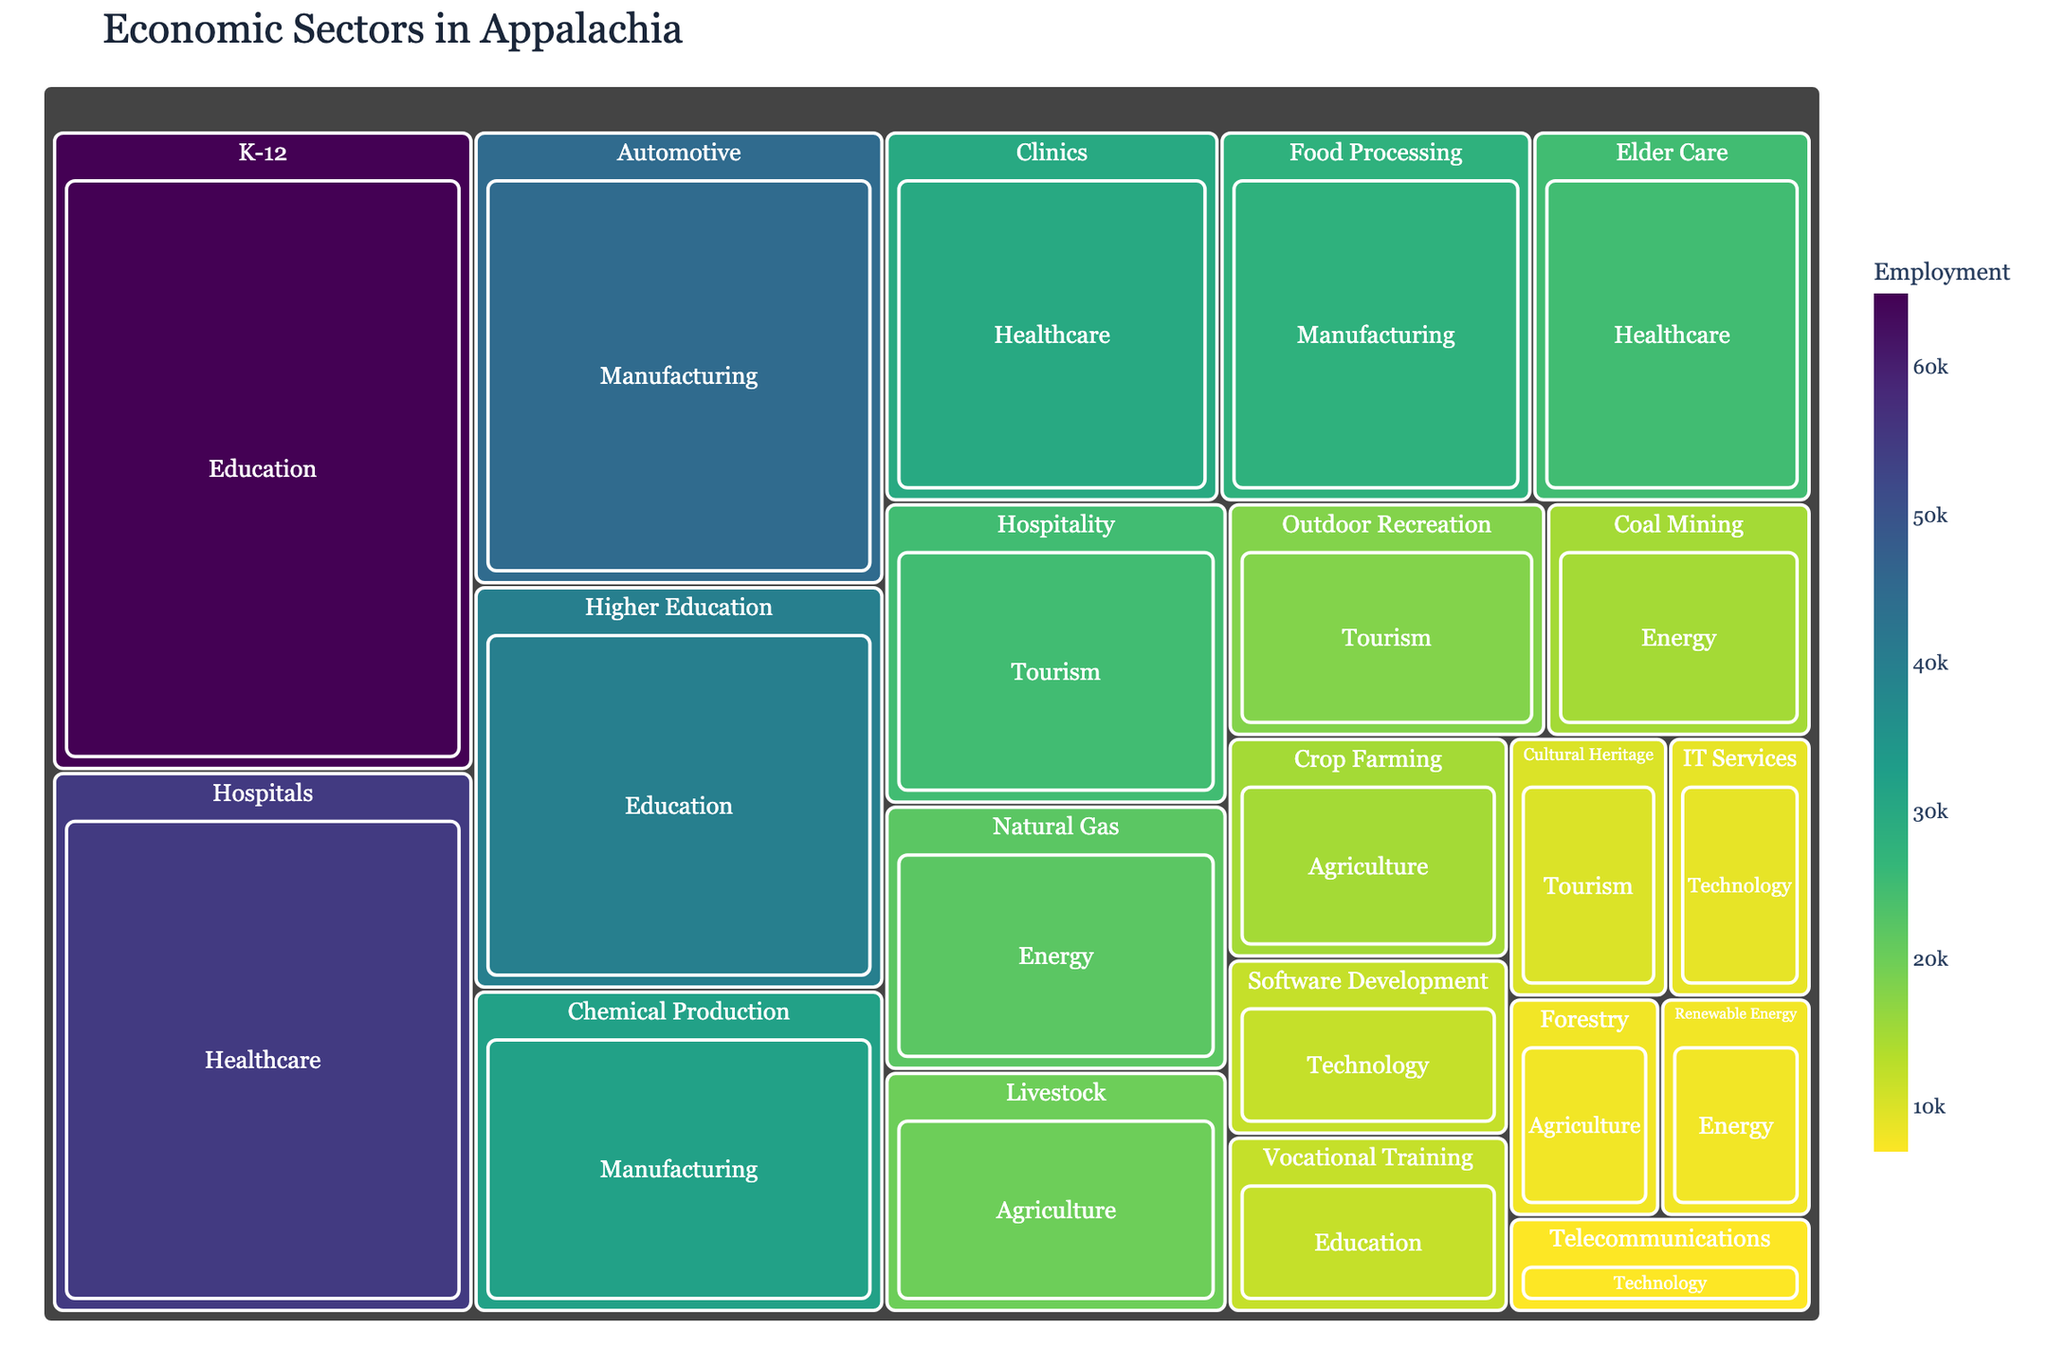Which industry has the highest employment in the Healthcare sector? Look at the sections within the Healthcare sector and find the industry with the largest area. The 'Hospitals' industry has the largest area, representing the highest employment.
Answer: Hospitals Which sector employs more people: Manufacturing or Education? Compare the total employment values from the Manufacturing and Education sectors shown in the treemap. Add the employment figures for each industry under both sectors and compare them.
Answer: Education What is the total employment in the Agriculture sector? Sum the employment values for all industries within the Agriculture sector: Livestock, Crop Farming, and Forestry. The total is 20,000 + 15,000 + 8,000 = 43,000.
Answer: 43,000 Which sector has the least employment? Identify the sector with the smallest area in the treemap. The Technology sector has the smallest overall area, indicating the least employment.
Answer: Technology How many more people are employed in K-12 education compared to Higher Education? Subtract the employment in Higher Education from that in K-12: 65,000 - 40,000. The result is 25,000 more people employed in K-12 education.
Answer: 25,000 In the Energy sector, which industry employs more people, Natural Gas or Coal Mining? Compare the employment values of the Natural Gas and Coal Mining industries within the Energy sector. Natural Gas employs 22,000, while Coal Mining employs 15,000. Hence, Natural Gas employs more people.
Answer: Natural Gas What percentage of the total employment in the Healthcare sector does Elder Care represent? Calculate the percentage of Elder Care employment out of the total Healthcare sector employment: (25,000 / (55,000 + 30,000 + 25,000)) * 100. The result is approximately 20.83%.
Answer: 20.83% Which industry in the Tourism sector has the second-highest employment? Identify the industries under the Tourism sector and find the one with the second-largest area after Hospitality. Outdoor Recreation has the second-highest employment with 18,000.
Answer: Outdoor Recreation What is the combined employment in Renewable Energy and Telecommunications? Add the employment values for Renewable Energy and Telecommunications: 8,000 + 7,000 = 15,000.
Answer: 15,000 